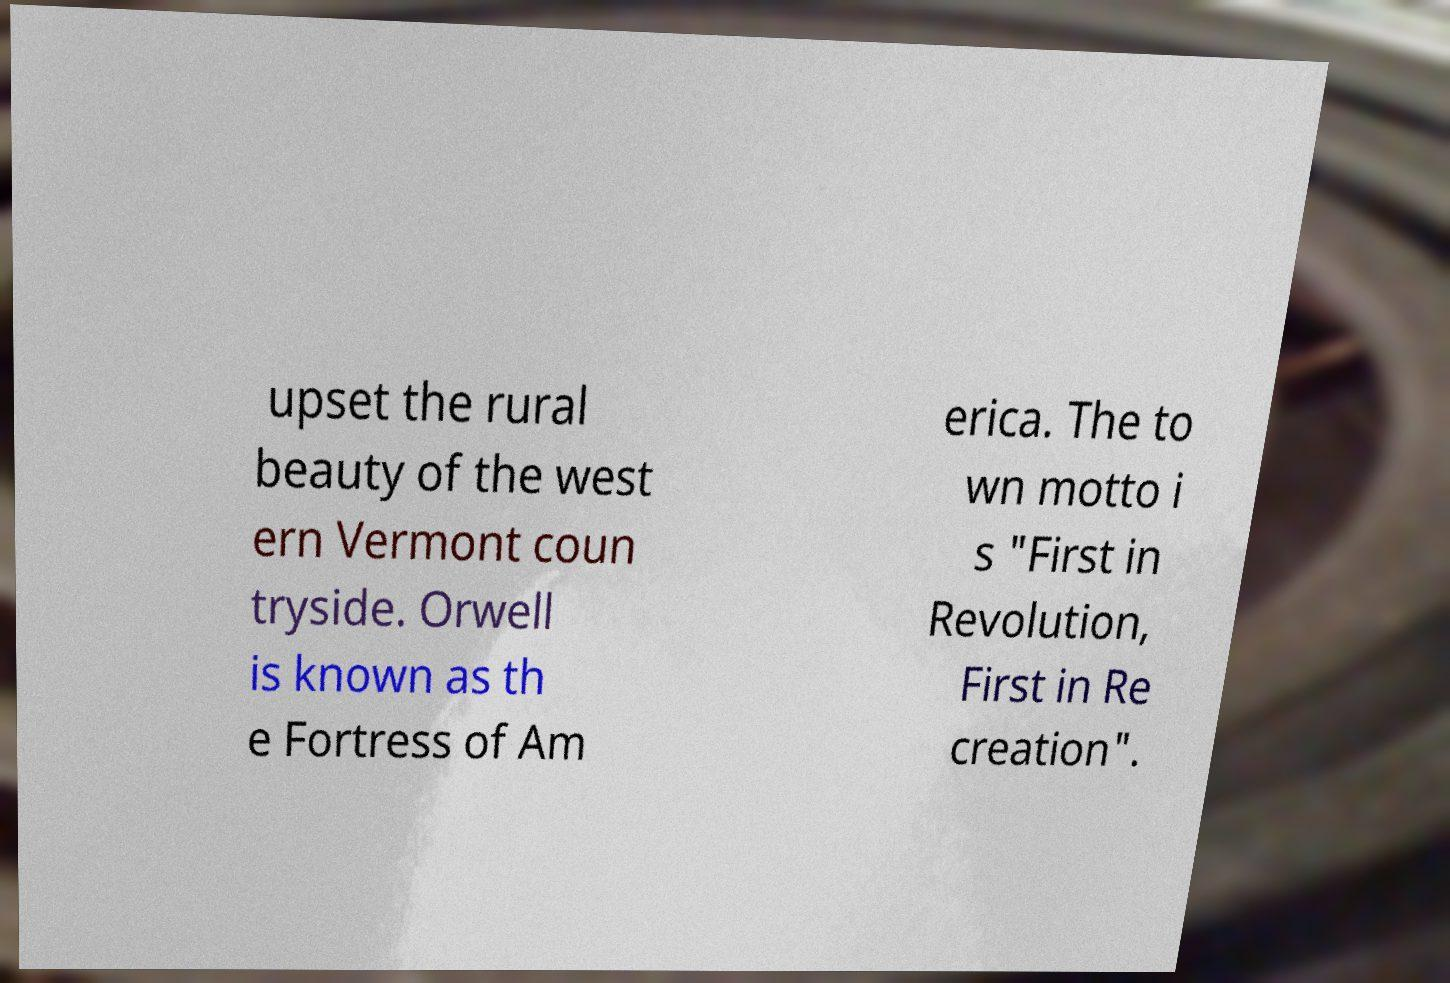Could you assist in decoding the text presented in this image and type it out clearly? upset the rural beauty of the west ern Vermont coun tryside. Orwell is known as th e Fortress of Am erica. The to wn motto i s "First in Revolution, First in Re creation". 